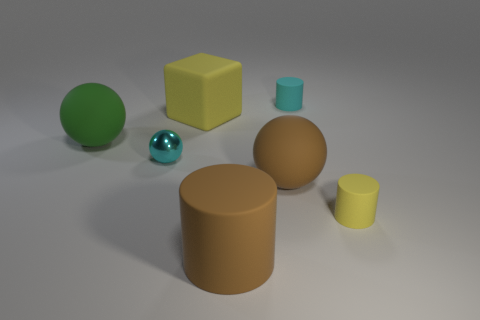Which of the objects in the image appears to be the most reflective? The object reflecting the most light and displaying a mirroring effect is the small spherical object, which bears a metallic, shiny surface likely akin to polished silver or chrome, suggesting a smooth and unblemished texture. 